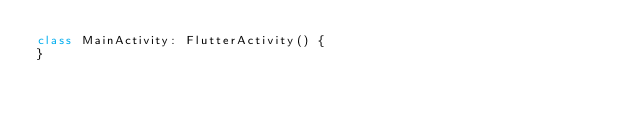Convert code to text. <code><loc_0><loc_0><loc_500><loc_500><_Kotlin_>class MainActivity: FlutterActivity() {
}
</code> 